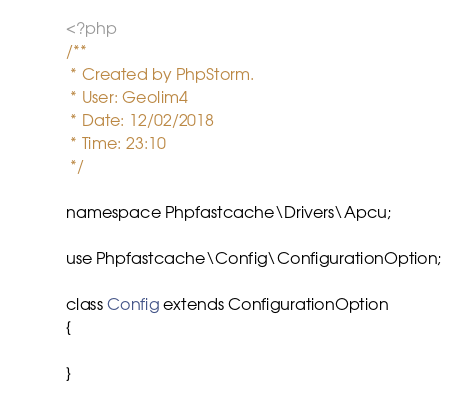<code> <loc_0><loc_0><loc_500><loc_500><_PHP_><?php
/**
 * Created by PhpStorm.
 * User: Geolim4
 * Date: 12/02/2018
 * Time: 23:10
 */

namespace Phpfastcache\Drivers\Apcu;

use Phpfastcache\Config\ConfigurationOption;

class Config extends ConfigurationOption
{

}</code> 